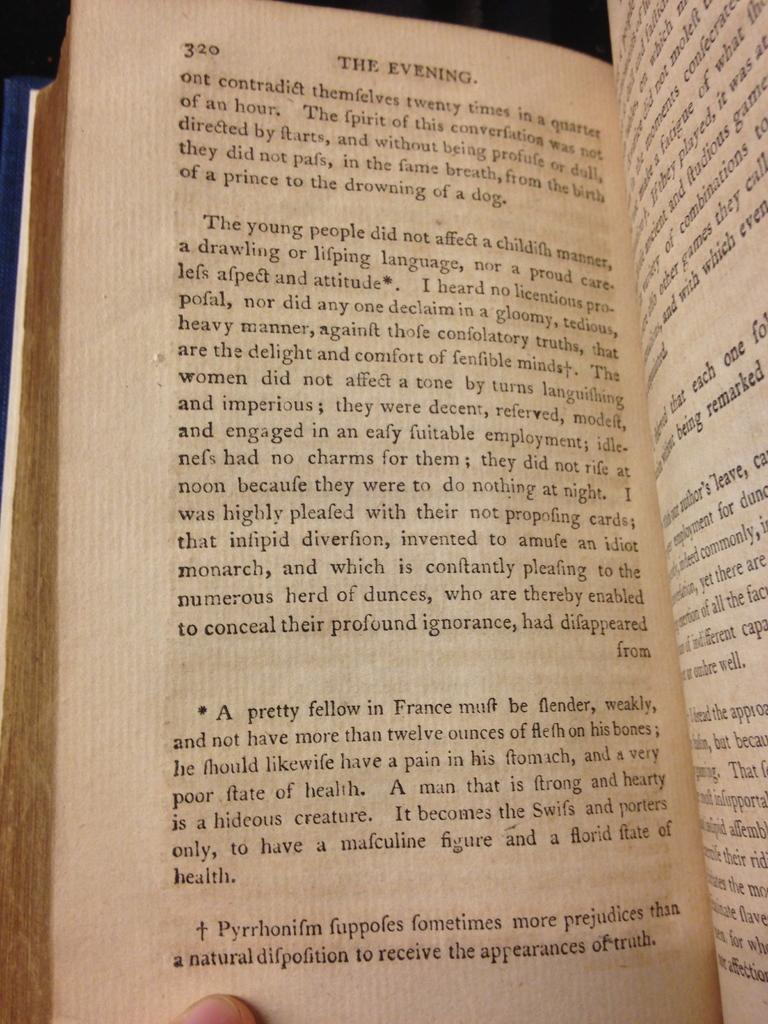<image>
Share a concise interpretation of the image provided. A book titled The Evening is open to page 320 